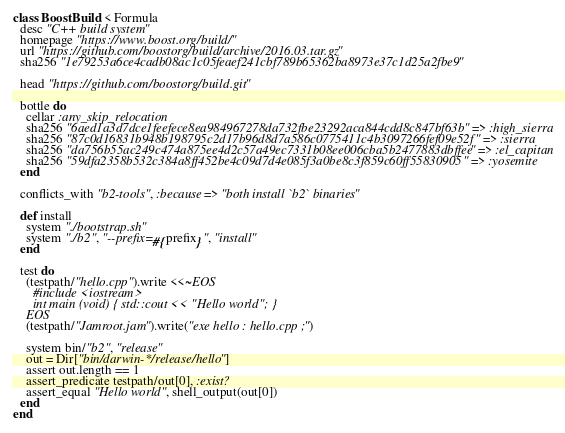<code> <loc_0><loc_0><loc_500><loc_500><_Ruby_>class BoostBuild < Formula
  desc "C++ build system"
  homepage "https://www.boost.org/build/"
  url "https://github.com/boostorg/build/archive/2016.03.tar.gz"
  sha256 "1e79253a6ce4cadb08ac1c05feaef241cbf789b65362ba8973e37c1d25a2fbe9"

  head "https://github.com/boostorg/build.git"

  bottle do
    cellar :any_skip_relocation
    sha256 "6aed1a3d7dce1feefece8ea984967278da732fbe23292aca844cdd8c847bf63b" => :high_sierra
    sha256 "87c0d16831b948b198795c2d17b96d8d7a586c0775411c4b3097266fef09e52f" => :sierra
    sha256 "da756b55ac249c474a875ee4d2c57a49ec7331b08ee006cba5b2477883dbffee" => :el_capitan
    sha256 "59dfa2358b532c384a8ff452be4c09d7d4e085f3a0be8c3f859c60ff55830905" => :yosemite
  end

  conflicts_with "b2-tools", :because => "both install `b2` binaries"

  def install
    system "./bootstrap.sh"
    system "./b2", "--prefix=#{prefix}", "install"
  end

  test do
    (testpath/"hello.cpp").write <<~EOS
      #include <iostream>
      int main (void) { std::cout << "Hello world"; }
    EOS
    (testpath/"Jamroot.jam").write("exe hello : hello.cpp ;")

    system bin/"b2", "release"
    out = Dir["bin/darwin-*/release/hello"]
    assert out.length == 1
    assert_predicate testpath/out[0], :exist?
    assert_equal "Hello world", shell_output(out[0])
  end
end
</code> 